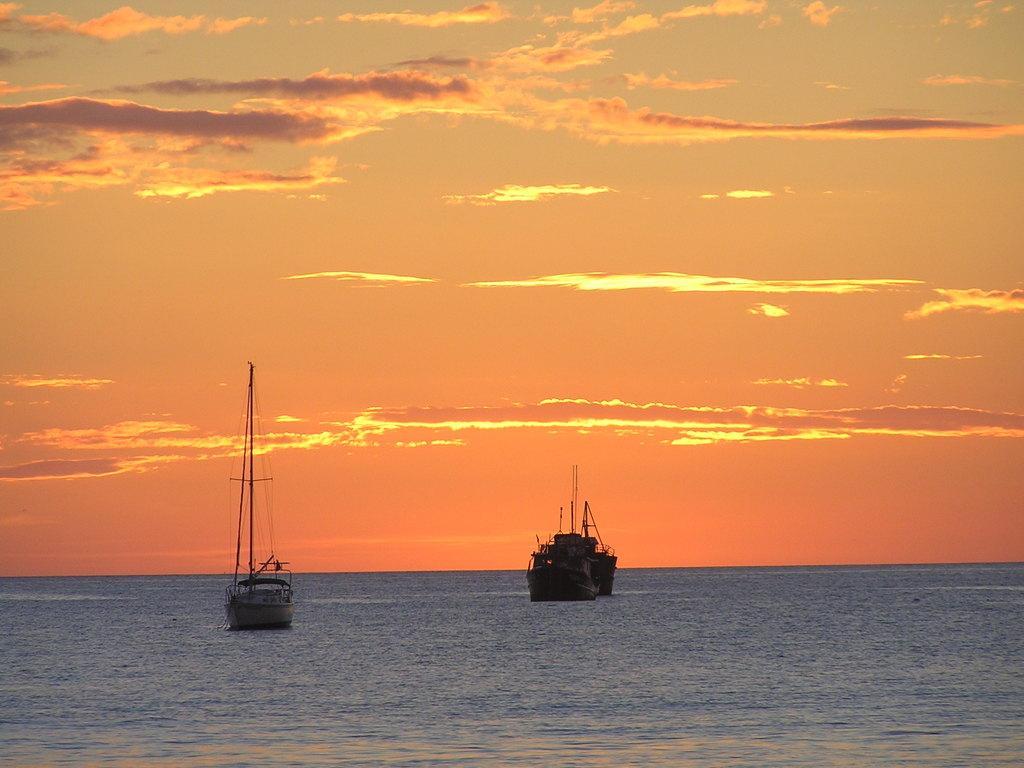Can you describe this image briefly? In the picture we can see some ships which are sailing on water and top of the picture there is orange color sky. 